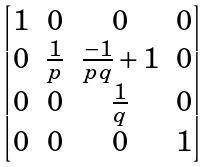Convert formula to latex. <formula><loc_0><loc_0><loc_500><loc_500>\begin{bmatrix} 1 & 0 & 0 & 0 \\ 0 & \frac { 1 } { p } & \frac { - 1 } { p q } + 1 & 0 \\ 0 & 0 & \frac { 1 } { q } & 0 \\ 0 & 0 & 0 & 1 \end{bmatrix}</formula> 